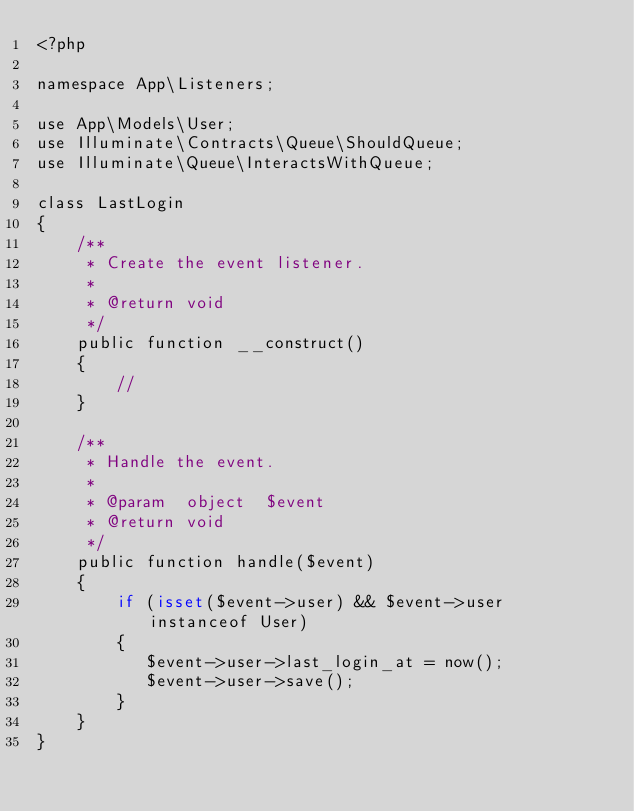Convert code to text. <code><loc_0><loc_0><loc_500><loc_500><_PHP_><?php

namespace App\Listeners;

use App\Models\User;
use Illuminate\Contracts\Queue\ShouldQueue;
use Illuminate\Queue\InteractsWithQueue;

class LastLogin
{
    /**
     * Create the event listener.
     *
     * @return void
     */
    public function __construct()
    {
        //
    }

    /**
     * Handle the event.
     *
     * @param  object  $event
     * @return void
     */
    public function handle($event)
    {
        if (isset($event->user) && $event->user instanceof User)
        {
           $event->user->last_login_at = now();
           $event->user->save();
        }
    }
}
</code> 